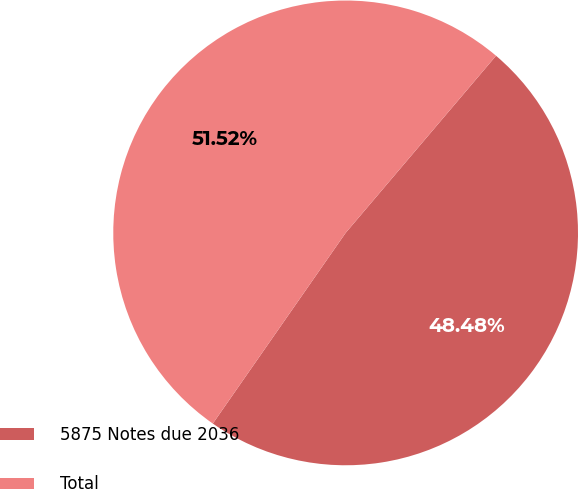Convert chart to OTSL. <chart><loc_0><loc_0><loc_500><loc_500><pie_chart><fcel>5875 Notes due 2036<fcel>Total<nl><fcel>48.48%<fcel>51.52%<nl></chart> 